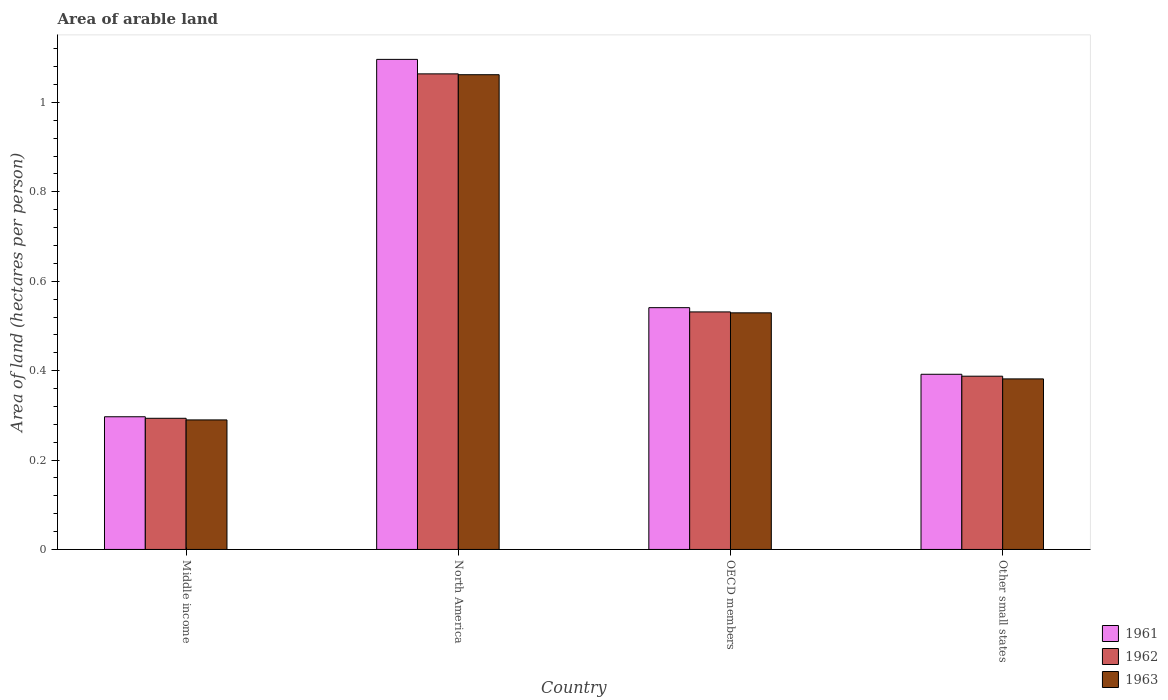Are the number of bars per tick equal to the number of legend labels?
Your answer should be compact. Yes. How many bars are there on the 2nd tick from the right?
Your response must be concise. 3. What is the label of the 1st group of bars from the left?
Provide a short and direct response. Middle income. What is the total arable land in 1962 in OECD members?
Provide a succinct answer. 0.53. Across all countries, what is the maximum total arable land in 1963?
Offer a terse response. 1.06. Across all countries, what is the minimum total arable land in 1963?
Provide a succinct answer. 0.29. What is the total total arable land in 1963 in the graph?
Make the answer very short. 2.26. What is the difference between the total arable land in 1962 in Middle income and that in North America?
Your answer should be compact. -0.77. What is the difference between the total arable land in 1962 in OECD members and the total arable land in 1961 in Other small states?
Provide a succinct answer. 0.14. What is the average total arable land in 1962 per country?
Provide a succinct answer. 0.57. What is the difference between the total arable land of/in 1962 and total arable land of/in 1963 in North America?
Make the answer very short. 0. What is the ratio of the total arable land in 1961 in OECD members to that in Other small states?
Make the answer very short. 1.38. Is the total arable land in 1963 in North America less than that in OECD members?
Offer a very short reply. No. What is the difference between the highest and the second highest total arable land in 1963?
Offer a terse response. -0.53. What is the difference between the highest and the lowest total arable land in 1962?
Your answer should be very brief. 0.77. In how many countries, is the total arable land in 1962 greater than the average total arable land in 1962 taken over all countries?
Give a very brief answer. 1. What does the 1st bar from the left in Middle income represents?
Make the answer very short. 1961. What does the 2nd bar from the right in OECD members represents?
Your response must be concise. 1962. How many bars are there?
Ensure brevity in your answer.  12. Are all the bars in the graph horizontal?
Provide a short and direct response. No. Where does the legend appear in the graph?
Your answer should be compact. Bottom right. How many legend labels are there?
Provide a succinct answer. 3. How are the legend labels stacked?
Your answer should be compact. Vertical. What is the title of the graph?
Provide a succinct answer. Area of arable land. Does "1988" appear as one of the legend labels in the graph?
Offer a very short reply. No. What is the label or title of the Y-axis?
Your answer should be compact. Area of land (hectares per person). What is the Area of land (hectares per person) in 1961 in Middle income?
Provide a succinct answer. 0.3. What is the Area of land (hectares per person) in 1962 in Middle income?
Give a very brief answer. 0.29. What is the Area of land (hectares per person) in 1963 in Middle income?
Your answer should be compact. 0.29. What is the Area of land (hectares per person) in 1961 in North America?
Provide a succinct answer. 1.1. What is the Area of land (hectares per person) of 1962 in North America?
Give a very brief answer. 1.06. What is the Area of land (hectares per person) in 1963 in North America?
Your response must be concise. 1.06. What is the Area of land (hectares per person) in 1961 in OECD members?
Give a very brief answer. 0.54. What is the Area of land (hectares per person) in 1962 in OECD members?
Provide a short and direct response. 0.53. What is the Area of land (hectares per person) in 1963 in OECD members?
Offer a very short reply. 0.53. What is the Area of land (hectares per person) of 1961 in Other small states?
Make the answer very short. 0.39. What is the Area of land (hectares per person) in 1962 in Other small states?
Your response must be concise. 0.39. What is the Area of land (hectares per person) in 1963 in Other small states?
Offer a terse response. 0.38. Across all countries, what is the maximum Area of land (hectares per person) of 1961?
Keep it short and to the point. 1.1. Across all countries, what is the maximum Area of land (hectares per person) in 1962?
Your answer should be very brief. 1.06. Across all countries, what is the maximum Area of land (hectares per person) in 1963?
Offer a terse response. 1.06. Across all countries, what is the minimum Area of land (hectares per person) in 1961?
Your answer should be compact. 0.3. Across all countries, what is the minimum Area of land (hectares per person) of 1962?
Keep it short and to the point. 0.29. Across all countries, what is the minimum Area of land (hectares per person) in 1963?
Ensure brevity in your answer.  0.29. What is the total Area of land (hectares per person) in 1961 in the graph?
Provide a succinct answer. 2.33. What is the total Area of land (hectares per person) of 1962 in the graph?
Offer a very short reply. 2.28. What is the total Area of land (hectares per person) in 1963 in the graph?
Provide a short and direct response. 2.26. What is the difference between the Area of land (hectares per person) of 1961 in Middle income and that in North America?
Offer a very short reply. -0.8. What is the difference between the Area of land (hectares per person) in 1962 in Middle income and that in North America?
Give a very brief answer. -0.77. What is the difference between the Area of land (hectares per person) in 1963 in Middle income and that in North America?
Provide a short and direct response. -0.77. What is the difference between the Area of land (hectares per person) in 1961 in Middle income and that in OECD members?
Provide a succinct answer. -0.24. What is the difference between the Area of land (hectares per person) in 1962 in Middle income and that in OECD members?
Provide a succinct answer. -0.24. What is the difference between the Area of land (hectares per person) in 1963 in Middle income and that in OECD members?
Keep it short and to the point. -0.24. What is the difference between the Area of land (hectares per person) in 1961 in Middle income and that in Other small states?
Offer a terse response. -0.1. What is the difference between the Area of land (hectares per person) of 1962 in Middle income and that in Other small states?
Offer a terse response. -0.09. What is the difference between the Area of land (hectares per person) of 1963 in Middle income and that in Other small states?
Keep it short and to the point. -0.09. What is the difference between the Area of land (hectares per person) of 1961 in North America and that in OECD members?
Offer a very short reply. 0.56. What is the difference between the Area of land (hectares per person) in 1962 in North America and that in OECD members?
Make the answer very short. 0.53. What is the difference between the Area of land (hectares per person) in 1963 in North America and that in OECD members?
Keep it short and to the point. 0.53. What is the difference between the Area of land (hectares per person) in 1961 in North America and that in Other small states?
Give a very brief answer. 0.7. What is the difference between the Area of land (hectares per person) of 1962 in North America and that in Other small states?
Provide a succinct answer. 0.68. What is the difference between the Area of land (hectares per person) in 1963 in North America and that in Other small states?
Offer a terse response. 0.68. What is the difference between the Area of land (hectares per person) in 1961 in OECD members and that in Other small states?
Provide a succinct answer. 0.15. What is the difference between the Area of land (hectares per person) of 1962 in OECD members and that in Other small states?
Provide a succinct answer. 0.14. What is the difference between the Area of land (hectares per person) in 1963 in OECD members and that in Other small states?
Offer a very short reply. 0.15. What is the difference between the Area of land (hectares per person) in 1961 in Middle income and the Area of land (hectares per person) in 1962 in North America?
Make the answer very short. -0.77. What is the difference between the Area of land (hectares per person) of 1961 in Middle income and the Area of land (hectares per person) of 1963 in North America?
Ensure brevity in your answer.  -0.77. What is the difference between the Area of land (hectares per person) in 1962 in Middle income and the Area of land (hectares per person) in 1963 in North America?
Give a very brief answer. -0.77. What is the difference between the Area of land (hectares per person) of 1961 in Middle income and the Area of land (hectares per person) of 1962 in OECD members?
Ensure brevity in your answer.  -0.23. What is the difference between the Area of land (hectares per person) of 1961 in Middle income and the Area of land (hectares per person) of 1963 in OECD members?
Provide a succinct answer. -0.23. What is the difference between the Area of land (hectares per person) in 1962 in Middle income and the Area of land (hectares per person) in 1963 in OECD members?
Your answer should be compact. -0.24. What is the difference between the Area of land (hectares per person) in 1961 in Middle income and the Area of land (hectares per person) in 1962 in Other small states?
Provide a short and direct response. -0.09. What is the difference between the Area of land (hectares per person) in 1961 in Middle income and the Area of land (hectares per person) in 1963 in Other small states?
Provide a succinct answer. -0.08. What is the difference between the Area of land (hectares per person) in 1962 in Middle income and the Area of land (hectares per person) in 1963 in Other small states?
Offer a very short reply. -0.09. What is the difference between the Area of land (hectares per person) of 1961 in North America and the Area of land (hectares per person) of 1962 in OECD members?
Make the answer very short. 0.56. What is the difference between the Area of land (hectares per person) of 1961 in North America and the Area of land (hectares per person) of 1963 in OECD members?
Provide a succinct answer. 0.57. What is the difference between the Area of land (hectares per person) in 1962 in North America and the Area of land (hectares per person) in 1963 in OECD members?
Provide a succinct answer. 0.53. What is the difference between the Area of land (hectares per person) in 1961 in North America and the Area of land (hectares per person) in 1962 in Other small states?
Offer a terse response. 0.71. What is the difference between the Area of land (hectares per person) of 1961 in North America and the Area of land (hectares per person) of 1963 in Other small states?
Make the answer very short. 0.71. What is the difference between the Area of land (hectares per person) of 1962 in North America and the Area of land (hectares per person) of 1963 in Other small states?
Ensure brevity in your answer.  0.68. What is the difference between the Area of land (hectares per person) in 1961 in OECD members and the Area of land (hectares per person) in 1962 in Other small states?
Your answer should be very brief. 0.15. What is the difference between the Area of land (hectares per person) in 1961 in OECD members and the Area of land (hectares per person) in 1963 in Other small states?
Keep it short and to the point. 0.16. What is the difference between the Area of land (hectares per person) of 1962 in OECD members and the Area of land (hectares per person) of 1963 in Other small states?
Offer a very short reply. 0.15. What is the average Area of land (hectares per person) in 1961 per country?
Ensure brevity in your answer.  0.58. What is the average Area of land (hectares per person) in 1962 per country?
Make the answer very short. 0.57. What is the average Area of land (hectares per person) of 1963 per country?
Ensure brevity in your answer.  0.57. What is the difference between the Area of land (hectares per person) of 1961 and Area of land (hectares per person) of 1962 in Middle income?
Give a very brief answer. 0. What is the difference between the Area of land (hectares per person) of 1961 and Area of land (hectares per person) of 1963 in Middle income?
Offer a terse response. 0.01. What is the difference between the Area of land (hectares per person) of 1962 and Area of land (hectares per person) of 1963 in Middle income?
Provide a short and direct response. 0. What is the difference between the Area of land (hectares per person) in 1961 and Area of land (hectares per person) in 1962 in North America?
Your response must be concise. 0.03. What is the difference between the Area of land (hectares per person) of 1961 and Area of land (hectares per person) of 1963 in North America?
Give a very brief answer. 0.03. What is the difference between the Area of land (hectares per person) of 1962 and Area of land (hectares per person) of 1963 in North America?
Offer a very short reply. 0. What is the difference between the Area of land (hectares per person) in 1961 and Area of land (hectares per person) in 1962 in OECD members?
Ensure brevity in your answer.  0.01. What is the difference between the Area of land (hectares per person) in 1961 and Area of land (hectares per person) in 1963 in OECD members?
Keep it short and to the point. 0.01. What is the difference between the Area of land (hectares per person) of 1962 and Area of land (hectares per person) of 1963 in OECD members?
Keep it short and to the point. 0. What is the difference between the Area of land (hectares per person) of 1961 and Area of land (hectares per person) of 1962 in Other small states?
Keep it short and to the point. 0. What is the difference between the Area of land (hectares per person) of 1961 and Area of land (hectares per person) of 1963 in Other small states?
Give a very brief answer. 0.01. What is the difference between the Area of land (hectares per person) in 1962 and Area of land (hectares per person) in 1963 in Other small states?
Your response must be concise. 0.01. What is the ratio of the Area of land (hectares per person) in 1961 in Middle income to that in North America?
Provide a succinct answer. 0.27. What is the ratio of the Area of land (hectares per person) of 1962 in Middle income to that in North America?
Give a very brief answer. 0.28. What is the ratio of the Area of land (hectares per person) of 1963 in Middle income to that in North America?
Your answer should be very brief. 0.27. What is the ratio of the Area of land (hectares per person) in 1961 in Middle income to that in OECD members?
Offer a terse response. 0.55. What is the ratio of the Area of land (hectares per person) of 1962 in Middle income to that in OECD members?
Your answer should be compact. 0.55. What is the ratio of the Area of land (hectares per person) in 1963 in Middle income to that in OECD members?
Make the answer very short. 0.55. What is the ratio of the Area of land (hectares per person) in 1961 in Middle income to that in Other small states?
Keep it short and to the point. 0.76. What is the ratio of the Area of land (hectares per person) in 1962 in Middle income to that in Other small states?
Make the answer very short. 0.76. What is the ratio of the Area of land (hectares per person) in 1963 in Middle income to that in Other small states?
Provide a succinct answer. 0.76. What is the ratio of the Area of land (hectares per person) of 1961 in North America to that in OECD members?
Make the answer very short. 2.03. What is the ratio of the Area of land (hectares per person) in 1962 in North America to that in OECD members?
Your response must be concise. 2. What is the ratio of the Area of land (hectares per person) in 1963 in North America to that in OECD members?
Your response must be concise. 2.01. What is the ratio of the Area of land (hectares per person) of 1961 in North America to that in Other small states?
Make the answer very short. 2.8. What is the ratio of the Area of land (hectares per person) in 1962 in North America to that in Other small states?
Provide a succinct answer. 2.75. What is the ratio of the Area of land (hectares per person) of 1963 in North America to that in Other small states?
Provide a short and direct response. 2.78. What is the ratio of the Area of land (hectares per person) of 1961 in OECD members to that in Other small states?
Make the answer very short. 1.38. What is the ratio of the Area of land (hectares per person) in 1962 in OECD members to that in Other small states?
Offer a terse response. 1.37. What is the ratio of the Area of land (hectares per person) in 1963 in OECD members to that in Other small states?
Provide a succinct answer. 1.39. What is the difference between the highest and the second highest Area of land (hectares per person) in 1961?
Make the answer very short. 0.56. What is the difference between the highest and the second highest Area of land (hectares per person) of 1962?
Your answer should be very brief. 0.53. What is the difference between the highest and the second highest Area of land (hectares per person) of 1963?
Provide a succinct answer. 0.53. What is the difference between the highest and the lowest Area of land (hectares per person) of 1961?
Ensure brevity in your answer.  0.8. What is the difference between the highest and the lowest Area of land (hectares per person) of 1962?
Offer a very short reply. 0.77. What is the difference between the highest and the lowest Area of land (hectares per person) in 1963?
Keep it short and to the point. 0.77. 